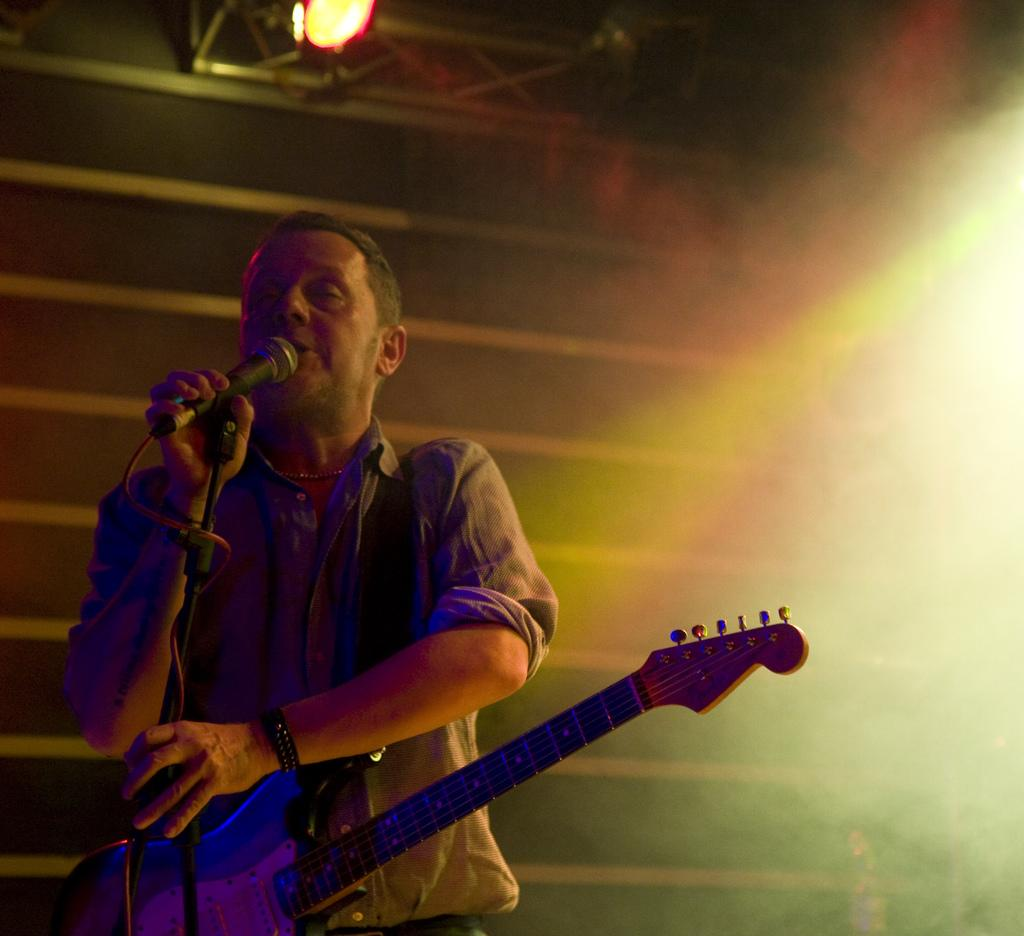What is the man in the image doing? The man is singing in the image. What is the man holding while singing? The man is holding a mic and stand. What can be seen in the background of the image? There is a light, a wall, and smoke in the background of the image. How many pigs are visible in the image? There are no pigs present in the image. What type of twig is being used as a prop in the image? There is no twig present in the image. 